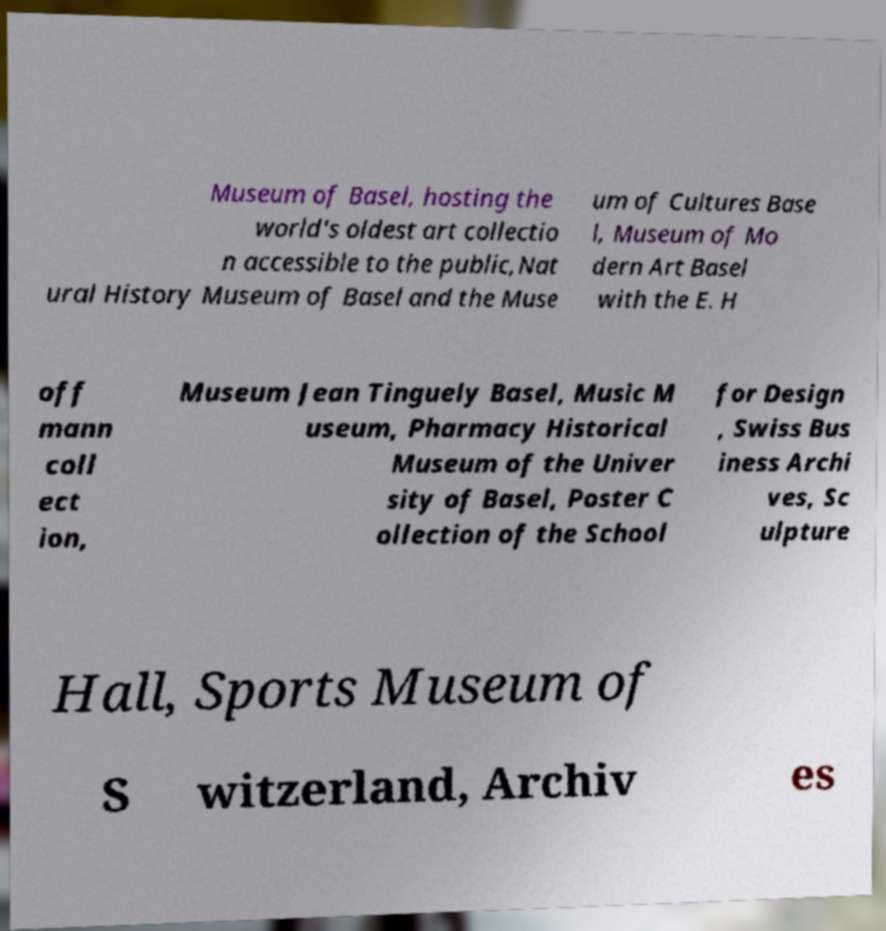Could you assist in decoding the text presented in this image and type it out clearly? Museum of Basel, hosting the world's oldest art collectio n accessible to the public,Nat ural History Museum of Basel and the Muse um of Cultures Base l, Museum of Mo dern Art Basel with the E. H off mann coll ect ion, Museum Jean Tinguely Basel, Music M useum, Pharmacy Historical Museum of the Univer sity of Basel, Poster C ollection of the School for Design , Swiss Bus iness Archi ves, Sc ulpture Hall, Sports Museum of S witzerland, Archiv es 